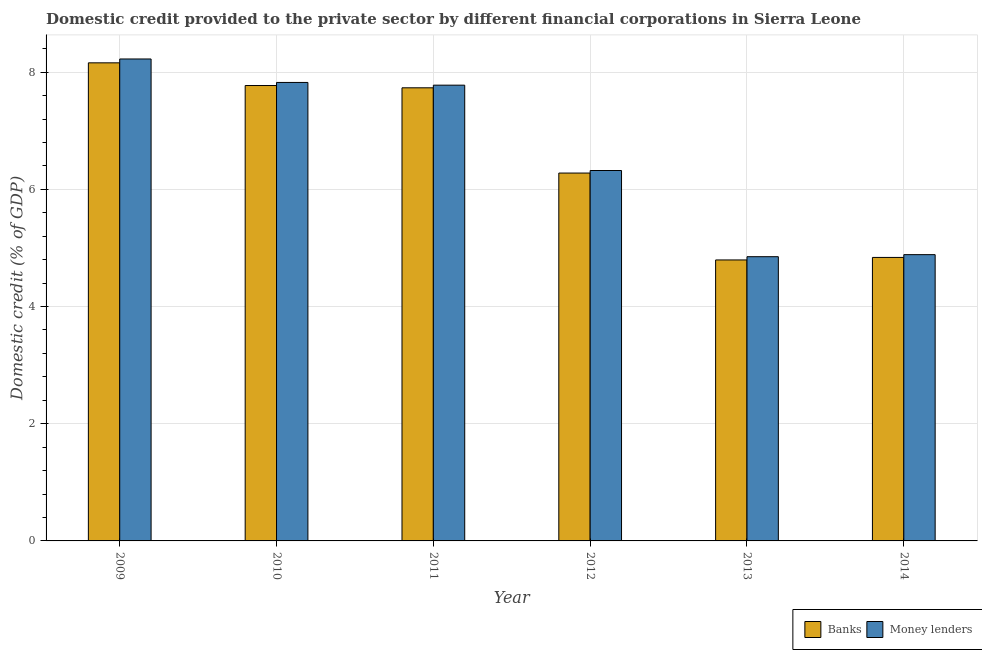How many groups of bars are there?
Keep it short and to the point. 6. Are the number of bars per tick equal to the number of legend labels?
Make the answer very short. Yes. How many bars are there on the 5th tick from the left?
Keep it short and to the point. 2. How many bars are there on the 1st tick from the right?
Make the answer very short. 2. In how many cases, is the number of bars for a given year not equal to the number of legend labels?
Offer a very short reply. 0. What is the domestic credit provided by money lenders in 2010?
Keep it short and to the point. 7.82. Across all years, what is the maximum domestic credit provided by money lenders?
Provide a short and direct response. 8.22. Across all years, what is the minimum domestic credit provided by banks?
Offer a terse response. 4.79. What is the total domestic credit provided by money lenders in the graph?
Provide a short and direct response. 39.88. What is the difference between the domestic credit provided by money lenders in 2012 and that in 2014?
Offer a very short reply. 1.44. What is the difference between the domestic credit provided by money lenders in 2011 and the domestic credit provided by banks in 2010?
Provide a short and direct response. -0.05. What is the average domestic credit provided by banks per year?
Provide a short and direct response. 6.6. In how many years, is the domestic credit provided by money lenders greater than 0.8 %?
Keep it short and to the point. 6. What is the ratio of the domestic credit provided by money lenders in 2013 to that in 2014?
Keep it short and to the point. 0.99. What is the difference between the highest and the second highest domestic credit provided by banks?
Make the answer very short. 0.39. What is the difference between the highest and the lowest domestic credit provided by money lenders?
Offer a very short reply. 3.37. In how many years, is the domestic credit provided by money lenders greater than the average domestic credit provided by money lenders taken over all years?
Your response must be concise. 3. Is the sum of the domestic credit provided by money lenders in 2009 and 2010 greater than the maximum domestic credit provided by banks across all years?
Ensure brevity in your answer.  Yes. What does the 1st bar from the left in 2012 represents?
Offer a very short reply. Banks. What does the 1st bar from the right in 2009 represents?
Offer a very short reply. Money lenders. How many bars are there?
Offer a very short reply. 12. How many years are there in the graph?
Ensure brevity in your answer.  6. Are the values on the major ticks of Y-axis written in scientific E-notation?
Give a very brief answer. No. Does the graph contain grids?
Your answer should be compact. Yes. How are the legend labels stacked?
Offer a terse response. Horizontal. What is the title of the graph?
Give a very brief answer. Domestic credit provided to the private sector by different financial corporations in Sierra Leone. Does "From human activities" appear as one of the legend labels in the graph?
Keep it short and to the point. No. What is the label or title of the Y-axis?
Give a very brief answer. Domestic credit (% of GDP). What is the Domestic credit (% of GDP) in Banks in 2009?
Make the answer very short. 8.16. What is the Domestic credit (% of GDP) in Money lenders in 2009?
Make the answer very short. 8.22. What is the Domestic credit (% of GDP) in Banks in 2010?
Offer a terse response. 7.77. What is the Domestic credit (% of GDP) in Money lenders in 2010?
Ensure brevity in your answer.  7.82. What is the Domestic credit (% of GDP) of Banks in 2011?
Keep it short and to the point. 7.73. What is the Domestic credit (% of GDP) of Money lenders in 2011?
Provide a short and direct response. 7.78. What is the Domestic credit (% of GDP) in Banks in 2012?
Your answer should be very brief. 6.28. What is the Domestic credit (% of GDP) in Money lenders in 2012?
Ensure brevity in your answer.  6.32. What is the Domestic credit (% of GDP) of Banks in 2013?
Your response must be concise. 4.79. What is the Domestic credit (% of GDP) of Money lenders in 2013?
Your answer should be compact. 4.85. What is the Domestic credit (% of GDP) of Banks in 2014?
Make the answer very short. 4.84. What is the Domestic credit (% of GDP) in Money lenders in 2014?
Offer a terse response. 4.89. Across all years, what is the maximum Domestic credit (% of GDP) in Banks?
Keep it short and to the point. 8.16. Across all years, what is the maximum Domestic credit (% of GDP) in Money lenders?
Make the answer very short. 8.22. Across all years, what is the minimum Domestic credit (% of GDP) of Banks?
Your answer should be compact. 4.79. Across all years, what is the minimum Domestic credit (% of GDP) in Money lenders?
Provide a succinct answer. 4.85. What is the total Domestic credit (% of GDP) of Banks in the graph?
Make the answer very short. 39.57. What is the total Domestic credit (% of GDP) of Money lenders in the graph?
Offer a terse response. 39.88. What is the difference between the Domestic credit (% of GDP) of Banks in 2009 and that in 2010?
Your response must be concise. 0.39. What is the difference between the Domestic credit (% of GDP) in Money lenders in 2009 and that in 2010?
Make the answer very short. 0.4. What is the difference between the Domestic credit (% of GDP) in Banks in 2009 and that in 2011?
Keep it short and to the point. 0.43. What is the difference between the Domestic credit (% of GDP) in Money lenders in 2009 and that in 2011?
Offer a terse response. 0.45. What is the difference between the Domestic credit (% of GDP) in Banks in 2009 and that in 2012?
Give a very brief answer. 1.88. What is the difference between the Domestic credit (% of GDP) in Money lenders in 2009 and that in 2012?
Your response must be concise. 1.9. What is the difference between the Domestic credit (% of GDP) in Banks in 2009 and that in 2013?
Offer a very short reply. 3.36. What is the difference between the Domestic credit (% of GDP) in Money lenders in 2009 and that in 2013?
Provide a short and direct response. 3.37. What is the difference between the Domestic credit (% of GDP) in Banks in 2009 and that in 2014?
Offer a terse response. 3.32. What is the difference between the Domestic credit (% of GDP) in Money lenders in 2009 and that in 2014?
Ensure brevity in your answer.  3.34. What is the difference between the Domestic credit (% of GDP) in Banks in 2010 and that in 2011?
Ensure brevity in your answer.  0.04. What is the difference between the Domestic credit (% of GDP) of Money lenders in 2010 and that in 2011?
Offer a very short reply. 0.05. What is the difference between the Domestic credit (% of GDP) in Banks in 2010 and that in 2012?
Ensure brevity in your answer.  1.49. What is the difference between the Domestic credit (% of GDP) of Money lenders in 2010 and that in 2012?
Provide a short and direct response. 1.5. What is the difference between the Domestic credit (% of GDP) of Banks in 2010 and that in 2013?
Provide a succinct answer. 2.98. What is the difference between the Domestic credit (% of GDP) of Money lenders in 2010 and that in 2013?
Ensure brevity in your answer.  2.97. What is the difference between the Domestic credit (% of GDP) of Banks in 2010 and that in 2014?
Offer a terse response. 2.93. What is the difference between the Domestic credit (% of GDP) in Money lenders in 2010 and that in 2014?
Provide a succinct answer. 2.94. What is the difference between the Domestic credit (% of GDP) of Banks in 2011 and that in 2012?
Offer a terse response. 1.45. What is the difference between the Domestic credit (% of GDP) in Money lenders in 2011 and that in 2012?
Provide a succinct answer. 1.46. What is the difference between the Domestic credit (% of GDP) in Banks in 2011 and that in 2013?
Your answer should be compact. 2.94. What is the difference between the Domestic credit (% of GDP) in Money lenders in 2011 and that in 2013?
Your answer should be compact. 2.93. What is the difference between the Domestic credit (% of GDP) of Banks in 2011 and that in 2014?
Offer a very short reply. 2.89. What is the difference between the Domestic credit (% of GDP) of Money lenders in 2011 and that in 2014?
Offer a very short reply. 2.89. What is the difference between the Domestic credit (% of GDP) of Banks in 2012 and that in 2013?
Provide a succinct answer. 1.48. What is the difference between the Domestic credit (% of GDP) of Money lenders in 2012 and that in 2013?
Give a very brief answer. 1.47. What is the difference between the Domestic credit (% of GDP) in Banks in 2012 and that in 2014?
Provide a short and direct response. 1.44. What is the difference between the Domestic credit (% of GDP) in Money lenders in 2012 and that in 2014?
Keep it short and to the point. 1.44. What is the difference between the Domestic credit (% of GDP) of Banks in 2013 and that in 2014?
Give a very brief answer. -0.04. What is the difference between the Domestic credit (% of GDP) in Money lenders in 2013 and that in 2014?
Keep it short and to the point. -0.03. What is the difference between the Domestic credit (% of GDP) of Banks in 2009 and the Domestic credit (% of GDP) of Money lenders in 2010?
Offer a very short reply. 0.33. What is the difference between the Domestic credit (% of GDP) of Banks in 2009 and the Domestic credit (% of GDP) of Money lenders in 2011?
Give a very brief answer. 0.38. What is the difference between the Domestic credit (% of GDP) of Banks in 2009 and the Domestic credit (% of GDP) of Money lenders in 2012?
Give a very brief answer. 1.84. What is the difference between the Domestic credit (% of GDP) in Banks in 2009 and the Domestic credit (% of GDP) in Money lenders in 2013?
Your answer should be very brief. 3.31. What is the difference between the Domestic credit (% of GDP) in Banks in 2009 and the Domestic credit (% of GDP) in Money lenders in 2014?
Keep it short and to the point. 3.27. What is the difference between the Domestic credit (% of GDP) of Banks in 2010 and the Domestic credit (% of GDP) of Money lenders in 2011?
Your response must be concise. -0.01. What is the difference between the Domestic credit (% of GDP) of Banks in 2010 and the Domestic credit (% of GDP) of Money lenders in 2012?
Ensure brevity in your answer.  1.45. What is the difference between the Domestic credit (% of GDP) of Banks in 2010 and the Domestic credit (% of GDP) of Money lenders in 2013?
Keep it short and to the point. 2.92. What is the difference between the Domestic credit (% of GDP) of Banks in 2010 and the Domestic credit (% of GDP) of Money lenders in 2014?
Your response must be concise. 2.89. What is the difference between the Domestic credit (% of GDP) in Banks in 2011 and the Domestic credit (% of GDP) in Money lenders in 2012?
Provide a succinct answer. 1.41. What is the difference between the Domestic credit (% of GDP) in Banks in 2011 and the Domestic credit (% of GDP) in Money lenders in 2013?
Your response must be concise. 2.88. What is the difference between the Domestic credit (% of GDP) in Banks in 2011 and the Domestic credit (% of GDP) in Money lenders in 2014?
Provide a succinct answer. 2.85. What is the difference between the Domestic credit (% of GDP) in Banks in 2012 and the Domestic credit (% of GDP) in Money lenders in 2013?
Offer a terse response. 1.43. What is the difference between the Domestic credit (% of GDP) of Banks in 2012 and the Domestic credit (% of GDP) of Money lenders in 2014?
Your answer should be very brief. 1.39. What is the difference between the Domestic credit (% of GDP) in Banks in 2013 and the Domestic credit (% of GDP) in Money lenders in 2014?
Provide a succinct answer. -0.09. What is the average Domestic credit (% of GDP) of Banks per year?
Your response must be concise. 6.6. What is the average Domestic credit (% of GDP) of Money lenders per year?
Your response must be concise. 6.65. In the year 2009, what is the difference between the Domestic credit (% of GDP) in Banks and Domestic credit (% of GDP) in Money lenders?
Your answer should be compact. -0.07. In the year 2010, what is the difference between the Domestic credit (% of GDP) of Banks and Domestic credit (% of GDP) of Money lenders?
Provide a short and direct response. -0.05. In the year 2011, what is the difference between the Domestic credit (% of GDP) in Banks and Domestic credit (% of GDP) in Money lenders?
Provide a succinct answer. -0.05. In the year 2012, what is the difference between the Domestic credit (% of GDP) in Banks and Domestic credit (% of GDP) in Money lenders?
Your answer should be very brief. -0.04. In the year 2013, what is the difference between the Domestic credit (% of GDP) of Banks and Domestic credit (% of GDP) of Money lenders?
Your response must be concise. -0.06. In the year 2014, what is the difference between the Domestic credit (% of GDP) of Banks and Domestic credit (% of GDP) of Money lenders?
Your answer should be compact. -0.05. What is the ratio of the Domestic credit (% of GDP) in Banks in 2009 to that in 2010?
Offer a terse response. 1.05. What is the ratio of the Domestic credit (% of GDP) in Money lenders in 2009 to that in 2010?
Ensure brevity in your answer.  1.05. What is the ratio of the Domestic credit (% of GDP) of Banks in 2009 to that in 2011?
Give a very brief answer. 1.06. What is the ratio of the Domestic credit (% of GDP) of Money lenders in 2009 to that in 2011?
Make the answer very short. 1.06. What is the ratio of the Domestic credit (% of GDP) of Banks in 2009 to that in 2012?
Make the answer very short. 1.3. What is the ratio of the Domestic credit (% of GDP) of Money lenders in 2009 to that in 2012?
Ensure brevity in your answer.  1.3. What is the ratio of the Domestic credit (% of GDP) of Banks in 2009 to that in 2013?
Make the answer very short. 1.7. What is the ratio of the Domestic credit (% of GDP) of Money lenders in 2009 to that in 2013?
Offer a very short reply. 1.7. What is the ratio of the Domestic credit (% of GDP) in Banks in 2009 to that in 2014?
Provide a short and direct response. 1.69. What is the ratio of the Domestic credit (% of GDP) of Money lenders in 2009 to that in 2014?
Ensure brevity in your answer.  1.68. What is the ratio of the Domestic credit (% of GDP) in Money lenders in 2010 to that in 2011?
Give a very brief answer. 1.01. What is the ratio of the Domestic credit (% of GDP) of Banks in 2010 to that in 2012?
Offer a terse response. 1.24. What is the ratio of the Domestic credit (% of GDP) of Money lenders in 2010 to that in 2012?
Your response must be concise. 1.24. What is the ratio of the Domestic credit (% of GDP) in Banks in 2010 to that in 2013?
Keep it short and to the point. 1.62. What is the ratio of the Domestic credit (% of GDP) of Money lenders in 2010 to that in 2013?
Offer a terse response. 1.61. What is the ratio of the Domestic credit (% of GDP) of Banks in 2010 to that in 2014?
Offer a terse response. 1.61. What is the ratio of the Domestic credit (% of GDP) in Money lenders in 2010 to that in 2014?
Keep it short and to the point. 1.6. What is the ratio of the Domestic credit (% of GDP) of Banks in 2011 to that in 2012?
Provide a succinct answer. 1.23. What is the ratio of the Domestic credit (% of GDP) of Money lenders in 2011 to that in 2012?
Keep it short and to the point. 1.23. What is the ratio of the Domestic credit (% of GDP) of Banks in 2011 to that in 2013?
Your answer should be compact. 1.61. What is the ratio of the Domestic credit (% of GDP) in Money lenders in 2011 to that in 2013?
Give a very brief answer. 1.6. What is the ratio of the Domestic credit (% of GDP) in Banks in 2011 to that in 2014?
Make the answer very short. 1.6. What is the ratio of the Domestic credit (% of GDP) of Money lenders in 2011 to that in 2014?
Provide a short and direct response. 1.59. What is the ratio of the Domestic credit (% of GDP) of Banks in 2012 to that in 2013?
Your answer should be compact. 1.31. What is the ratio of the Domestic credit (% of GDP) of Money lenders in 2012 to that in 2013?
Make the answer very short. 1.3. What is the ratio of the Domestic credit (% of GDP) in Banks in 2012 to that in 2014?
Give a very brief answer. 1.3. What is the ratio of the Domestic credit (% of GDP) of Money lenders in 2012 to that in 2014?
Provide a succinct answer. 1.29. What is the ratio of the Domestic credit (% of GDP) in Banks in 2013 to that in 2014?
Provide a short and direct response. 0.99. What is the difference between the highest and the second highest Domestic credit (% of GDP) of Banks?
Offer a very short reply. 0.39. What is the difference between the highest and the second highest Domestic credit (% of GDP) of Money lenders?
Offer a terse response. 0.4. What is the difference between the highest and the lowest Domestic credit (% of GDP) in Banks?
Give a very brief answer. 3.36. What is the difference between the highest and the lowest Domestic credit (% of GDP) of Money lenders?
Provide a short and direct response. 3.37. 